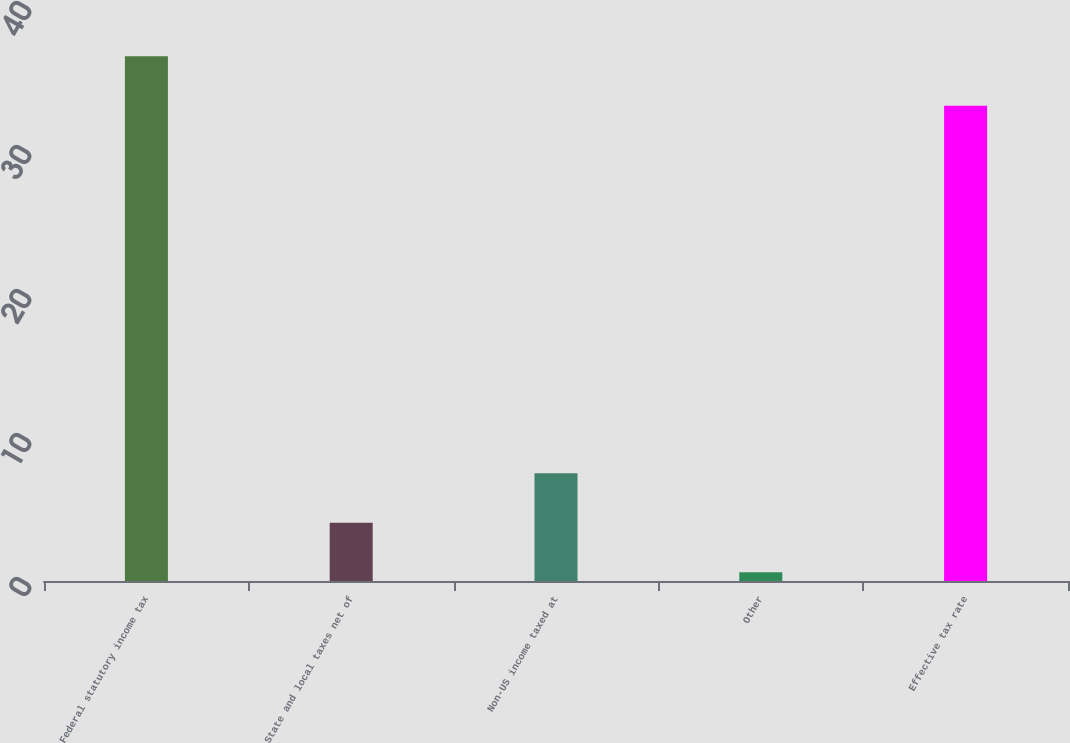<chart> <loc_0><loc_0><loc_500><loc_500><bar_chart><fcel>Federal statutory income tax<fcel>State and local taxes net of<fcel>Non-US income taxed at<fcel>Other<fcel>Effective tax rate<nl><fcel>36.44<fcel>4.04<fcel>7.48<fcel>0.6<fcel>33<nl></chart> 